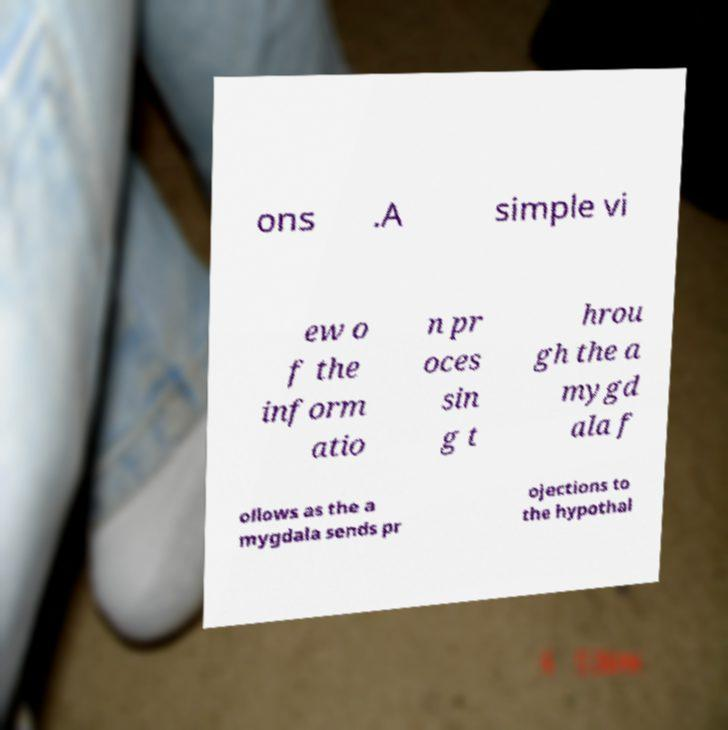Could you extract and type out the text from this image? ons .A simple vi ew o f the inform atio n pr oces sin g t hrou gh the a mygd ala f ollows as the a mygdala sends pr ojections to the hypothal 